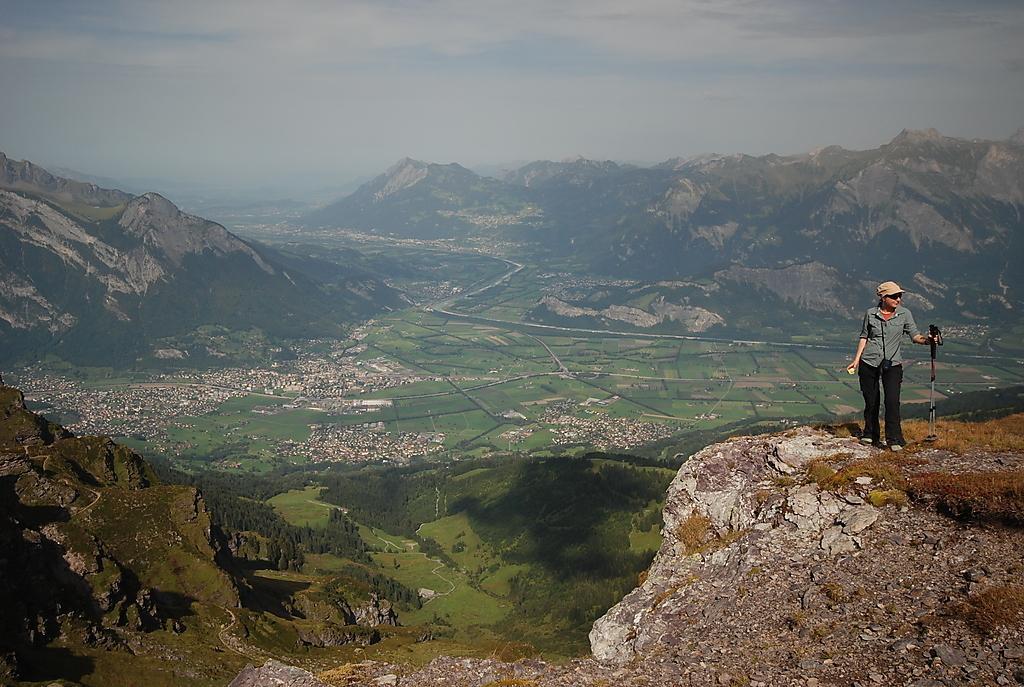Could you give a brief overview of what you see in this image? In the foreground of this picture, there is a woman standing on the rock holding a tripod stand. In the background, we can see mountains, city, trees, path, the sky and the cloud. 